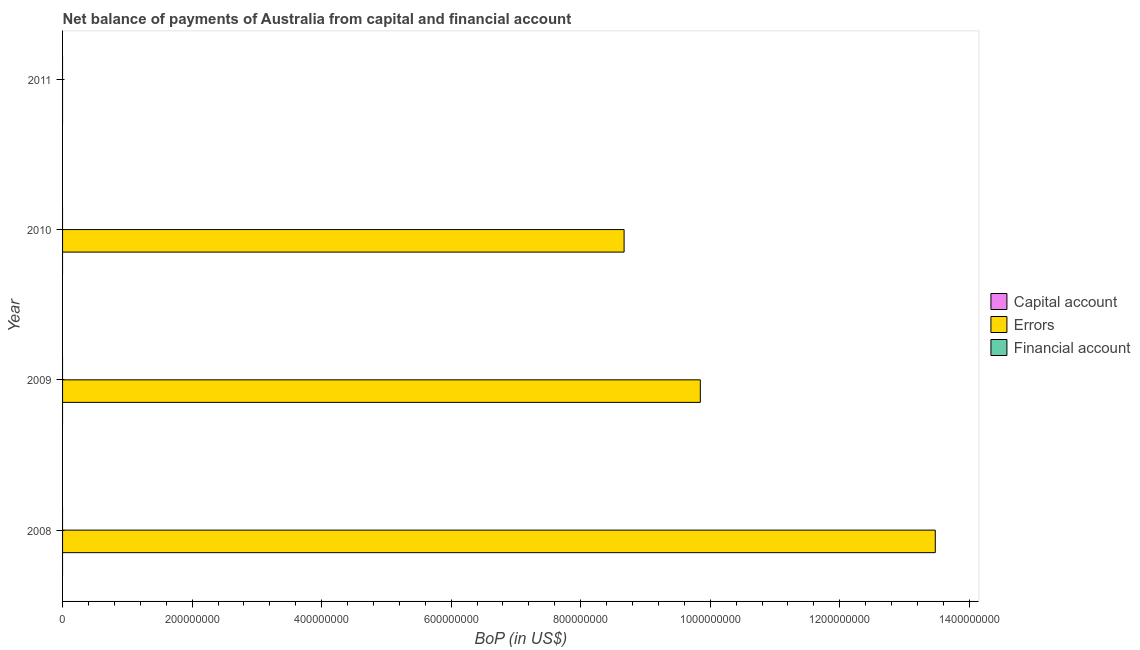How many bars are there on the 1st tick from the bottom?
Give a very brief answer. 1. In how many cases, is the number of bars for a given year not equal to the number of legend labels?
Offer a very short reply. 4. Across all years, what is the maximum amount of errors?
Make the answer very short. 1.35e+09. Across all years, what is the minimum amount of financial account?
Give a very brief answer. 0. In which year was the amount of errors maximum?
Ensure brevity in your answer.  2008. What is the total amount of errors in the graph?
Your response must be concise. 3.20e+09. What is the difference between the amount of errors in 2008 and that in 2009?
Your answer should be very brief. 3.63e+08. What is the average amount of errors per year?
Offer a terse response. 8.00e+08. What is the ratio of the amount of errors in 2008 to that in 2009?
Keep it short and to the point. 1.37. What is the difference between the highest and the second highest amount of errors?
Your response must be concise. 3.63e+08. What is the difference between the highest and the lowest amount of errors?
Provide a succinct answer. 1.35e+09. Is it the case that in every year, the sum of the amount of net capital account and amount of errors is greater than the amount of financial account?
Offer a terse response. No. Does the graph contain grids?
Provide a short and direct response. No. How are the legend labels stacked?
Provide a short and direct response. Vertical. What is the title of the graph?
Offer a very short reply. Net balance of payments of Australia from capital and financial account. Does "Tertiary education" appear as one of the legend labels in the graph?
Provide a succinct answer. No. What is the label or title of the X-axis?
Your answer should be compact. BoP (in US$). What is the BoP (in US$) in Capital account in 2008?
Provide a succinct answer. 0. What is the BoP (in US$) of Errors in 2008?
Provide a short and direct response. 1.35e+09. What is the BoP (in US$) in Errors in 2009?
Your answer should be very brief. 9.85e+08. What is the BoP (in US$) in Financial account in 2009?
Ensure brevity in your answer.  0. What is the BoP (in US$) in Capital account in 2010?
Your response must be concise. 0. What is the BoP (in US$) of Errors in 2010?
Keep it short and to the point. 8.67e+08. What is the BoP (in US$) of Financial account in 2010?
Ensure brevity in your answer.  0. What is the BoP (in US$) in Capital account in 2011?
Offer a very short reply. 0. What is the BoP (in US$) of Errors in 2011?
Offer a terse response. 0. What is the BoP (in US$) in Financial account in 2011?
Ensure brevity in your answer.  0. Across all years, what is the maximum BoP (in US$) of Errors?
Keep it short and to the point. 1.35e+09. What is the total BoP (in US$) of Capital account in the graph?
Offer a very short reply. 0. What is the total BoP (in US$) in Errors in the graph?
Make the answer very short. 3.20e+09. What is the difference between the BoP (in US$) in Errors in 2008 and that in 2009?
Provide a succinct answer. 3.63e+08. What is the difference between the BoP (in US$) in Errors in 2008 and that in 2010?
Give a very brief answer. 4.80e+08. What is the difference between the BoP (in US$) in Errors in 2009 and that in 2010?
Make the answer very short. 1.18e+08. What is the average BoP (in US$) of Capital account per year?
Provide a short and direct response. 0. What is the average BoP (in US$) in Errors per year?
Your answer should be compact. 8.00e+08. What is the ratio of the BoP (in US$) in Errors in 2008 to that in 2009?
Keep it short and to the point. 1.37. What is the ratio of the BoP (in US$) in Errors in 2008 to that in 2010?
Keep it short and to the point. 1.55. What is the ratio of the BoP (in US$) of Errors in 2009 to that in 2010?
Provide a short and direct response. 1.14. What is the difference between the highest and the second highest BoP (in US$) of Errors?
Keep it short and to the point. 3.63e+08. What is the difference between the highest and the lowest BoP (in US$) of Errors?
Make the answer very short. 1.35e+09. 